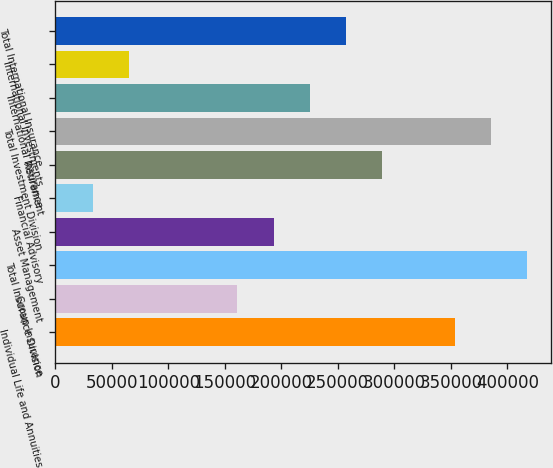Convert chart. <chart><loc_0><loc_0><loc_500><loc_500><bar_chart><fcel>Individual Life and Annuities<fcel>Group Insurance<fcel>Total Insurance Division<fcel>Asset Management<fcel>Financial Advisory<fcel>Retirement<fcel>Total Investment Division<fcel>International Insurance<fcel>International Investments<fcel>Total International Insurance<nl><fcel>353304<fcel>161122<fcel>417366<fcel>193152<fcel>32999.5<fcel>289244<fcel>385335<fcel>225182<fcel>65030<fcel>257213<nl></chart> 